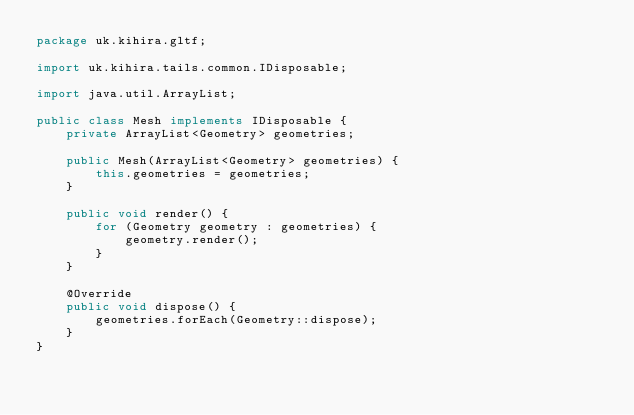Convert code to text. <code><loc_0><loc_0><loc_500><loc_500><_Java_>package uk.kihira.gltf;

import uk.kihira.tails.common.IDisposable;

import java.util.ArrayList;

public class Mesh implements IDisposable {
    private ArrayList<Geometry> geometries;

    public Mesh(ArrayList<Geometry> geometries) {
        this.geometries = geometries;
    }

    public void render() {
        for (Geometry geometry : geometries) {
            geometry.render();
        }
    }

    @Override
    public void dispose() {
        geometries.forEach(Geometry::dispose);
    }
}</code> 